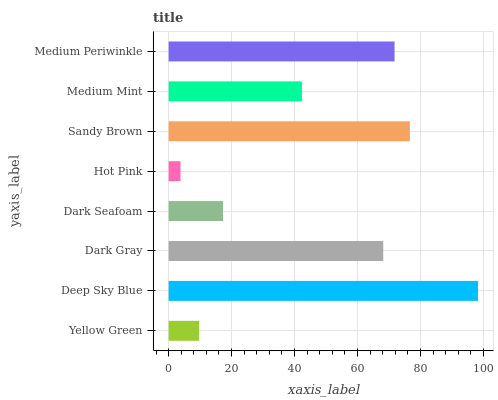Is Hot Pink the minimum?
Answer yes or no. Yes. Is Deep Sky Blue the maximum?
Answer yes or no. Yes. Is Dark Gray the minimum?
Answer yes or no. No. Is Dark Gray the maximum?
Answer yes or no. No. Is Deep Sky Blue greater than Dark Gray?
Answer yes or no. Yes. Is Dark Gray less than Deep Sky Blue?
Answer yes or no. Yes. Is Dark Gray greater than Deep Sky Blue?
Answer yes or no. No. Is Deep Sky Blue less than Dark Gray?
Answer yes or no. No. Is Dark Gray the high median?
Answer yes or no. Yes. Is Medium Mint the low median?
Answer yes or no. Yes. Is Sandy Brown the high median?
Answer yes or no. No. Is Deep Sky Blue the low median?
Answer yes or no. No. 